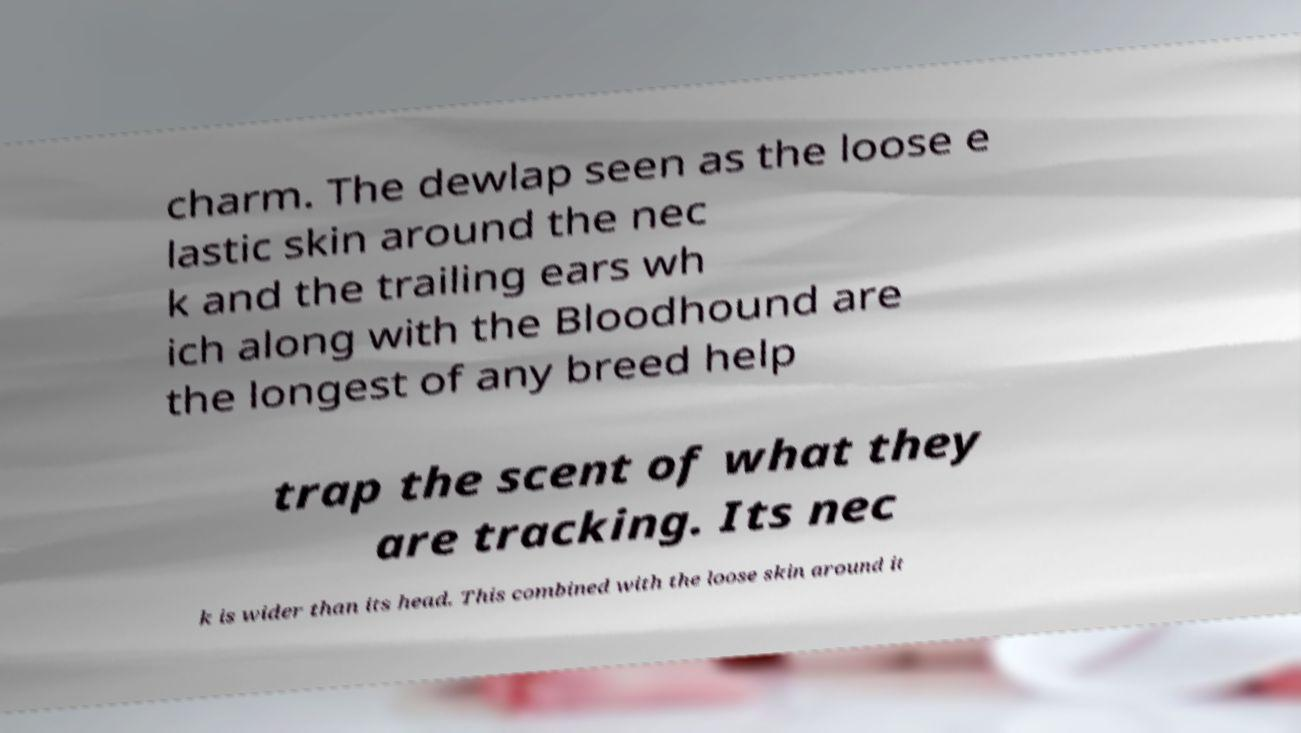Can you read and provide the text displayed in the image?This photo seems to have some interesting text. Can you extract and type it out for me? charm. The dewlap seen as the loose e lastic skin around the nec k and the trailing ears wh ich along with the Bloodhound are the longest of any breed help trap the scent of what they are tracking. Its nec k is wider than its head. This combined with the loose skin around it 